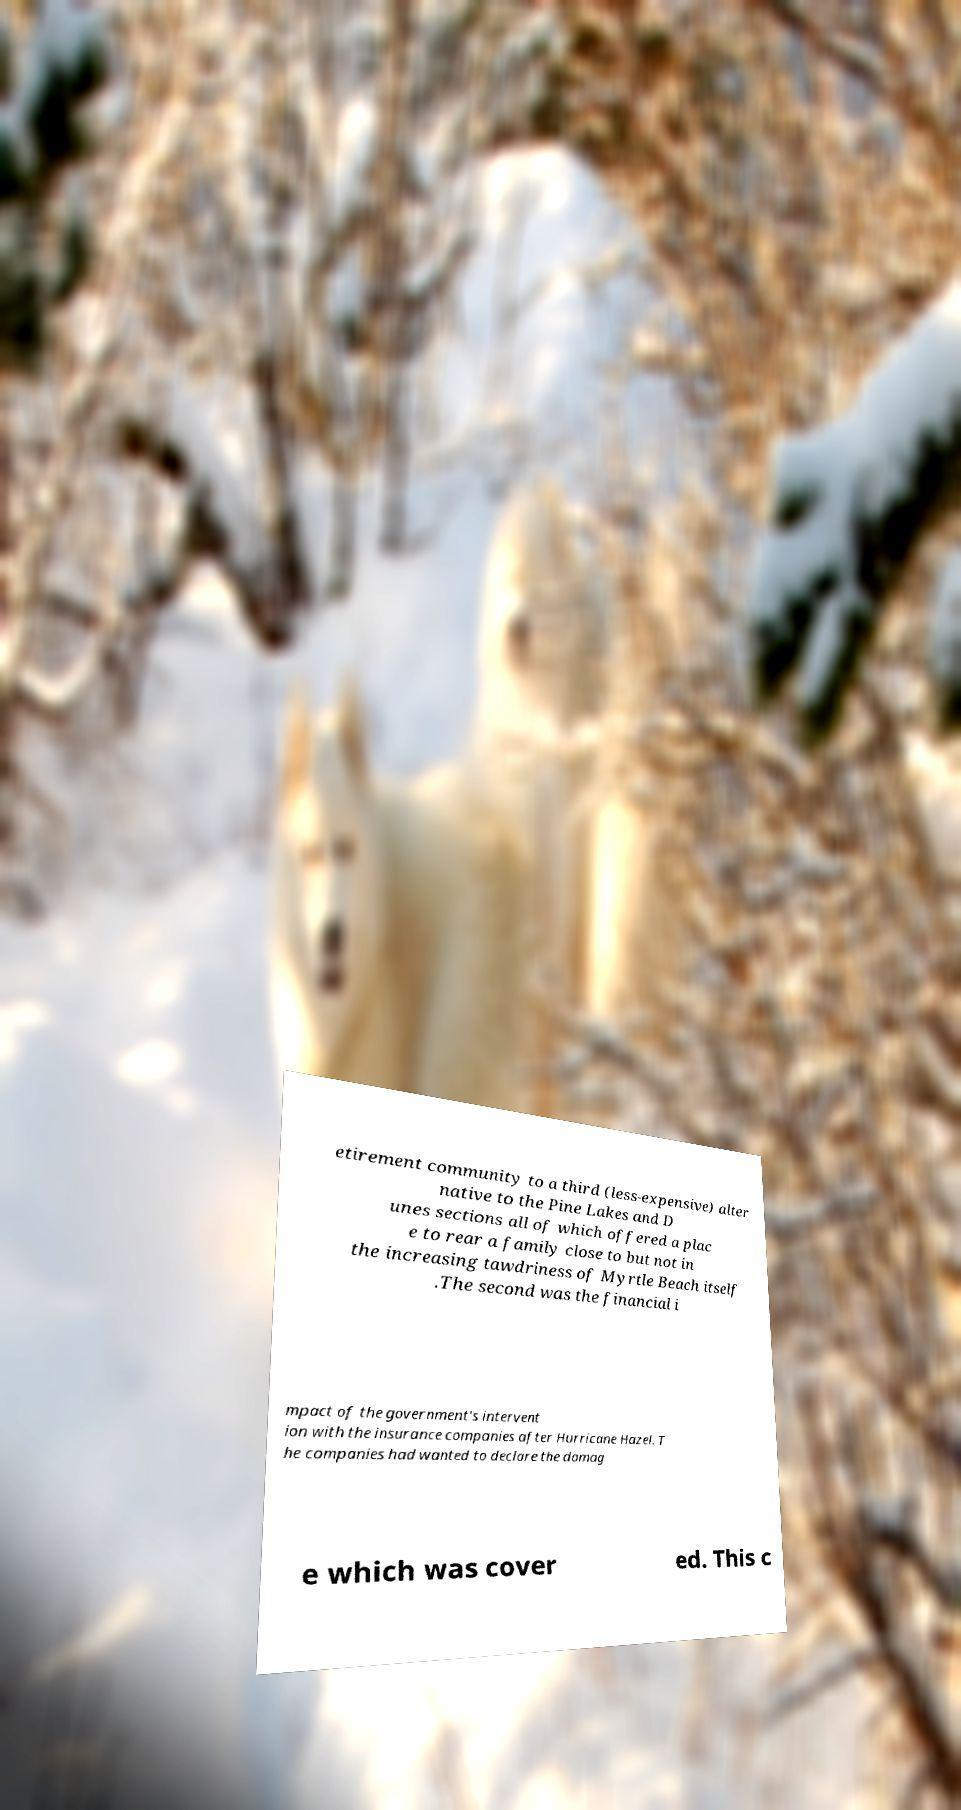Could you assist in decoding the text presented in this image and type it out clearly? etirement community to a third (less-expensive) alter native to the Pine Lakes and D unes sections all of which offered a plac e to rear a family close to but not in the increasing tawdriness of Myrtle Beach itself .The second was the financial i mpact of the government's intervent ion with the insurance companies after Hurricane Hazel. T he companies had wanted to declare the damag e which was cover ed. This c 